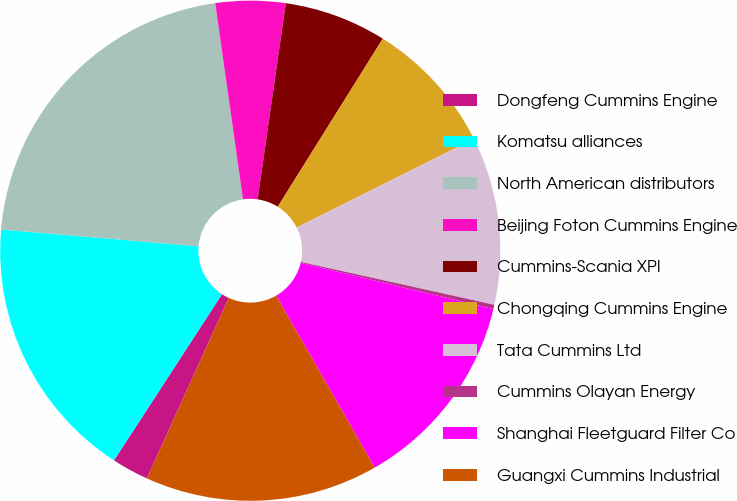<chart> <loc_0><loc_0><loc_500><loc_500><pie_chart><fcel>Dongfeng Cummins Engine<fcel>Komatsu alliances<fcel>North American distributors<fcel>Beijing Foton Cummins Engine<fcel>Cummins-Scania XPI<fcel>Chongqing Cummins Engine<fcel>Tata Cummins Ltd<fcel>Cummins Olayan Energy<fcel>Shanghai Fleetguard Filter Co<fcel>Guangxi Cummins Industrial<nl><fcel>2.39%<fcel>17.18%<fcel>21.41%<fcel>4.51%<fcel>6.62%<fcel>8.73%<fcel>10.85%<fcel>0.28%<fcel>12.96%<fcel>15.07%<nl></chart> 